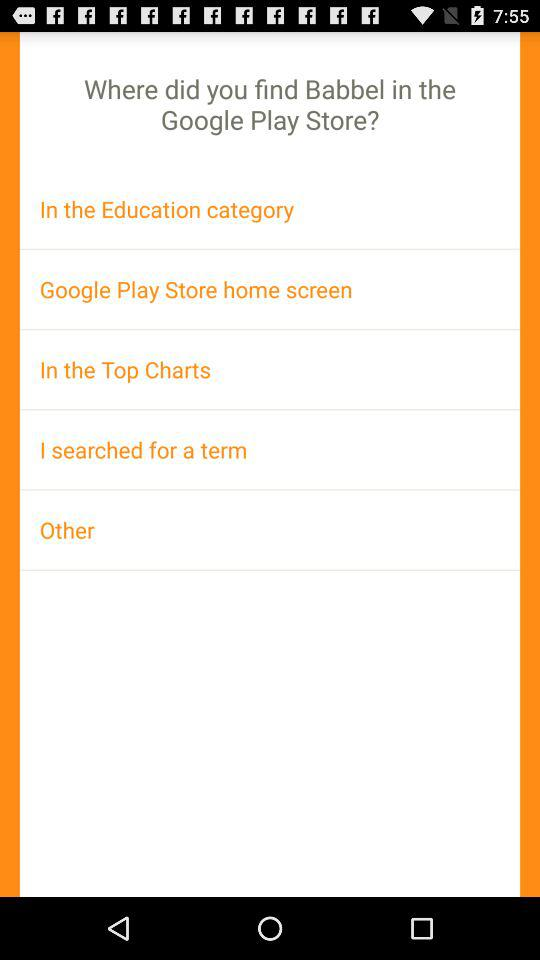How many options are there for finding Babbel in the Google Play Store?
Answer the question using a single word or phrase. 5 